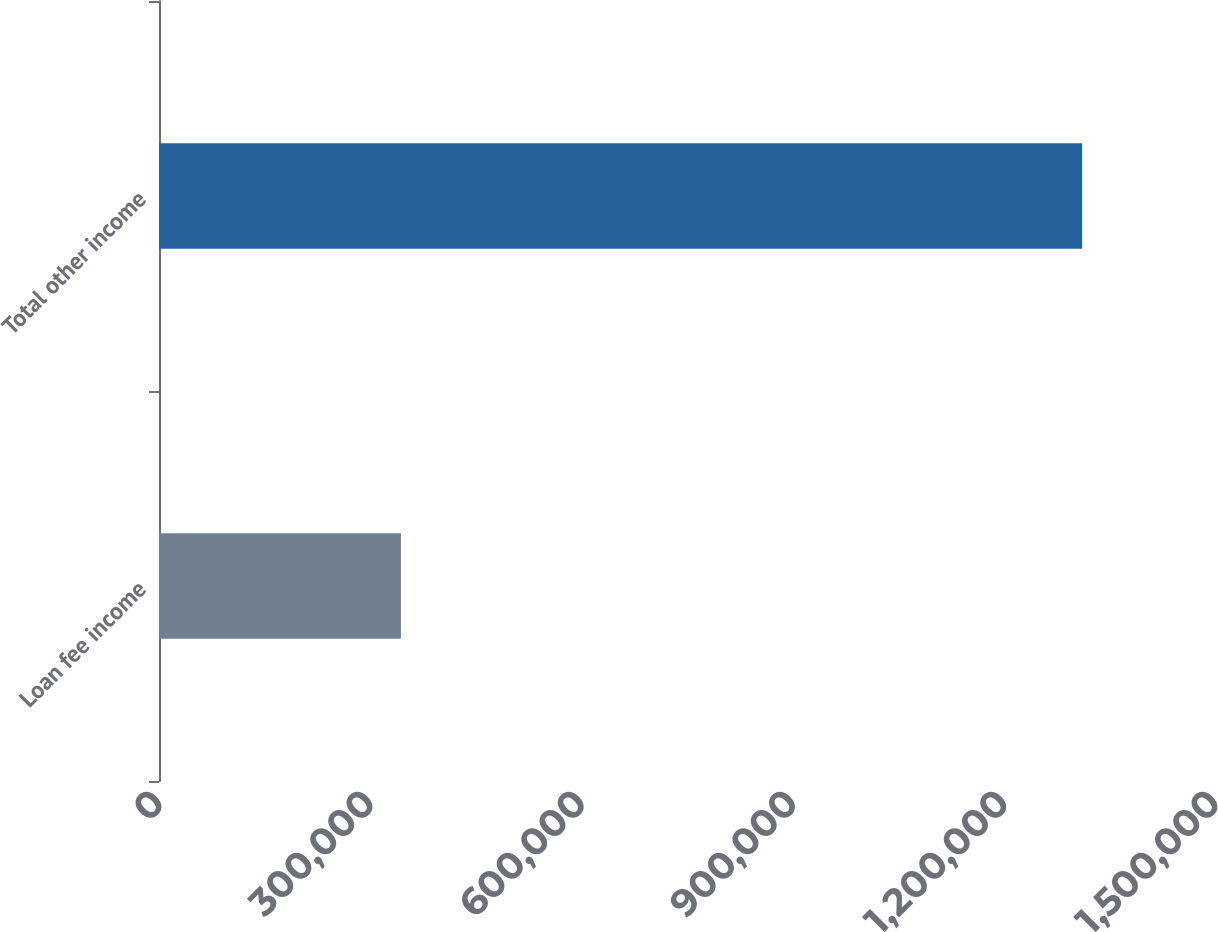Convert chart to OTSL. <chart><loc_0><loc_0><loc_500><loc_500><bar_chart><fcel>Loan fee income<fcel>Total other income<nl><fcel>343605<fcel>1.31136e+06<nl></chart> 